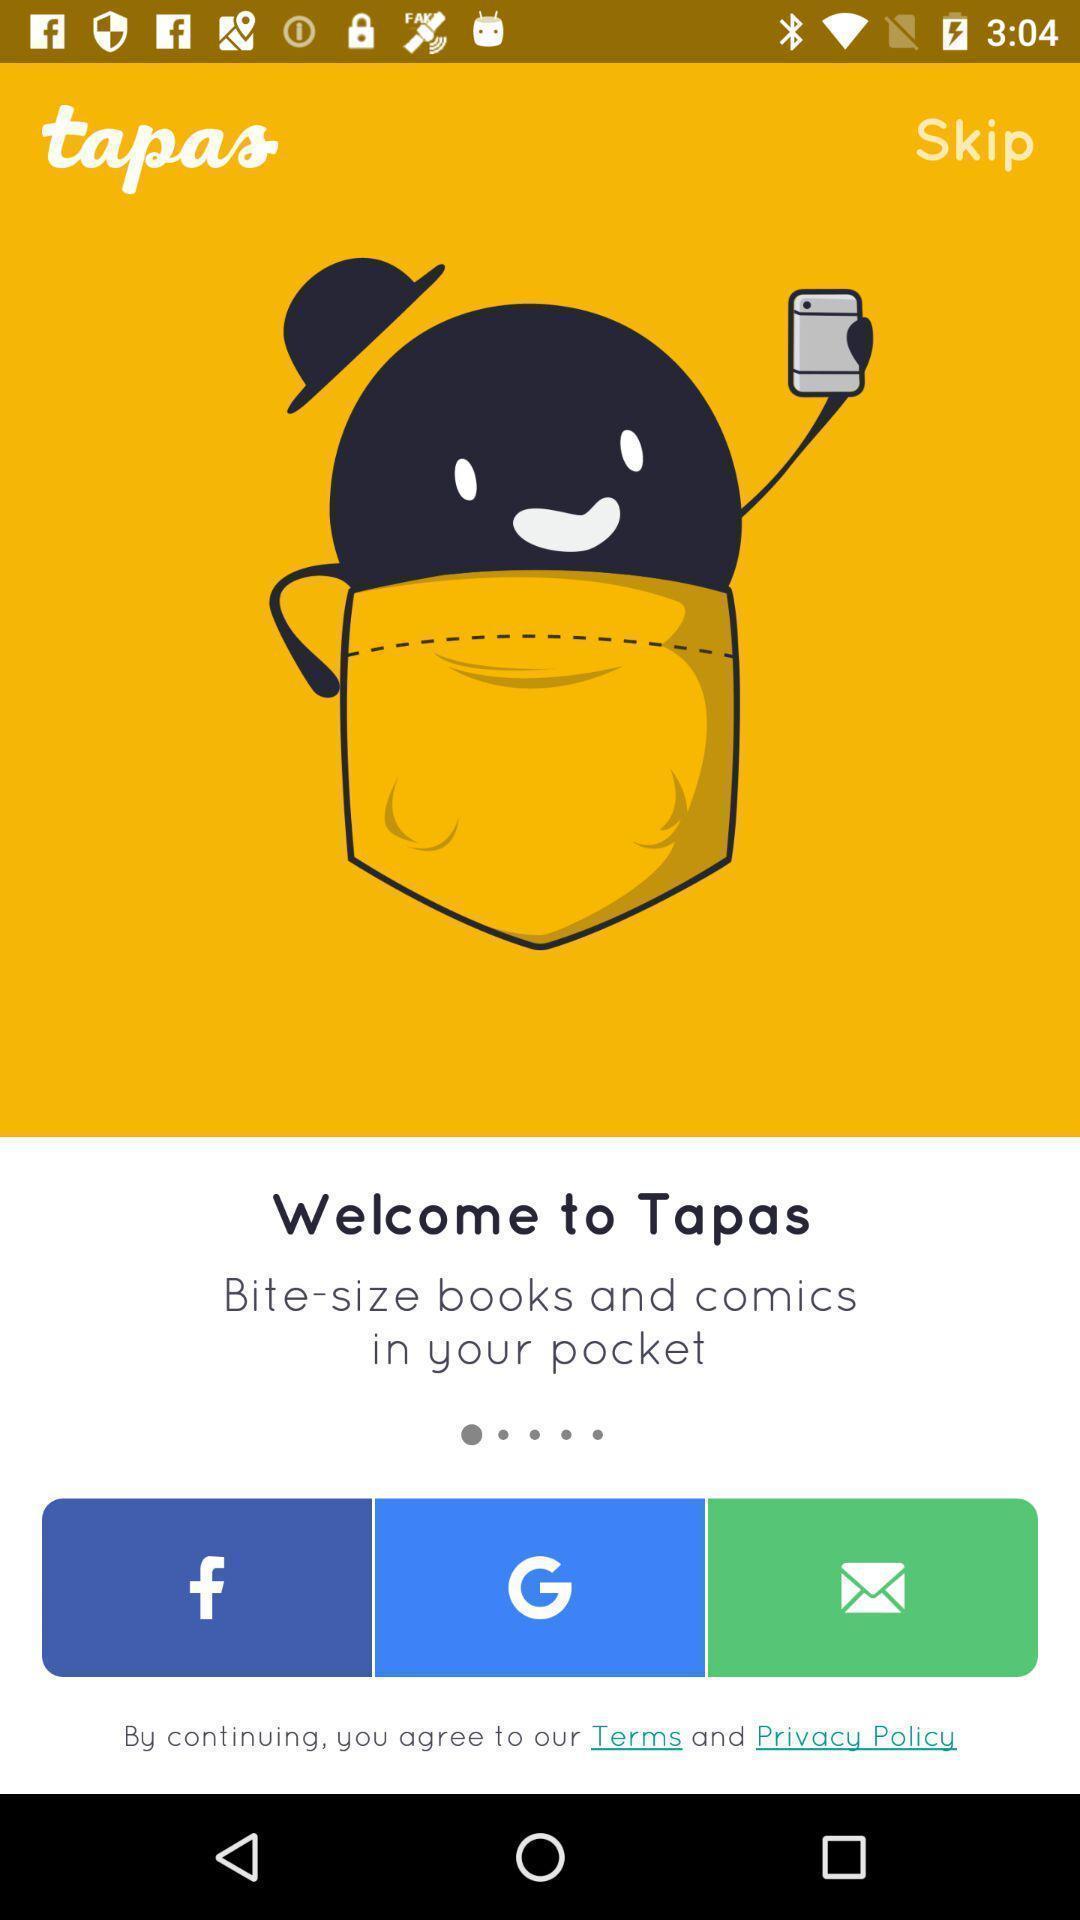Tell me what you see in this picture. Welcome page. 